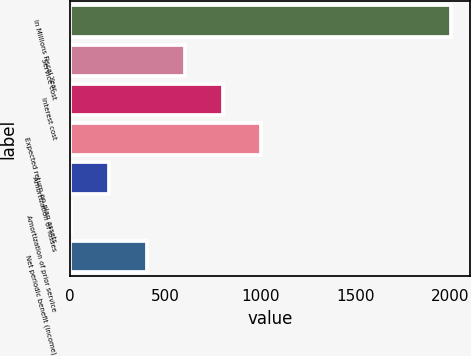<chart> <loc_0><loc_0><loc_500><loc_500><bar_chart><fcel>In Millions Fiscal Year<fcel>Service cost<fcel>Interest cost<fcel>Expected return on plan assets<fcel>Amortization of losses<fcel>Amortization of prior service<fcel>Net periodic benefit (income)<nl><fcel>2005<fcel>605.7<fcel>805.6<fcel>1005.5<fcel>205.9<fcel>6<fcel>405.8<nl></chart> 